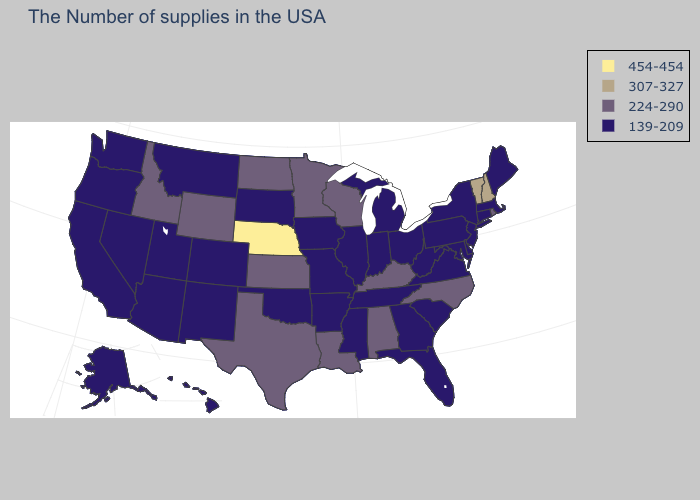What is the highest value in the South ?
Write a very short answer. 224-290. Name the states that have a value in the range 139-209?
Write a very short answer. Maine, Massachusetts, Connecticut, New York, New Jersey, Delaware, Maryland, Pennsylvania, Virginia, South Carolina, West Virginia, Ohio, Florida, Georgia, Michigan, Indiana, Tennessee, Illinois, Mississippi, Missouri, Arkansas, Iowa, Oklahoma, South Dakota, Colorado, New Mexico, Utah, Montana, Arizona, Nevada, California, Washington, Oregon, Alaska, Hawaii. Among the states that border Wyoming , which have the lowest value?
Give a very brief answer. South Dakota, Colorado, Utah, Montana. Does the map have missing data?
Be succinct. No. Name the states that have a value in the range 307-327?
Quick response, please. New Hampshire, Vermont. Name the states that have a value in the range 307-327?
Quick response, please. New Hampshire, Vermont. What is the value of Florida?
Write a very short answer. 139-209. Does Nebraska have the highest value in the USA?
Quick response, please. Yes. Among the states that border Indiana , which have the lowest value?
Concise answer only. Ohio, Michigan, Illinois. Is the legend a continuous bar?
Short answer required. No. Name the states that have a value in the range 454-454?
Give a very brief answer. Nebraska. What is the highest value in the USA?
Short answer required. 454-454. What is the highest value in the South ?
Concise answer only. 224-290. What is the value of Montana?
Write a very short answer. 139-209. What is the value of Utah?
Concise answer only. 139-209. 